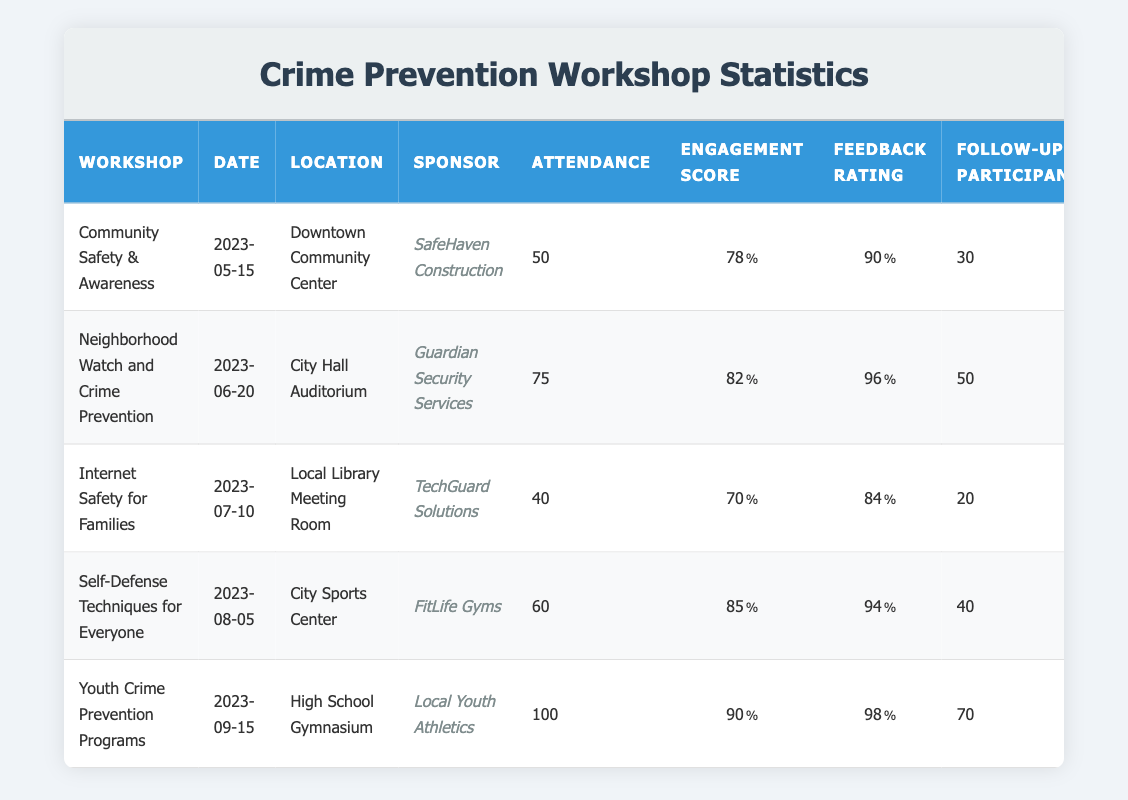What is the title of the workshop with the highest feedback rating? The table shows the feedback ratings for all workshops. The highest feedback rating is 4.9, which corresponds to the "Youth Crime Prevention Programs" workshop.
Answer: Youth Crime Prevention Programs How many follow-up participants attended the "Self-Defense Techniques for Everyone" workshop? By looking at the row for the "Self-Defense Techniques for Everyone" workshop, we find that there were 40 follow-up participants.
Answer: 40 What was the engagement score for the workshop held at the City Hall Auditorium? The workshop held at the City Hall Auditorium was "Neighborhood Watch and Crime Prevention," which has an engagement score of 82.
Answer: 82 What is the total attendance across all workshops? To find the total attendance, we need to sum the attendance figures: 50 + 75 + 40 + 60 + 100 = 325.
Answer: 325 Is it true that the workshop titled "Internet Safety for Families" had a higher engagement score than the "Community Safety & Awareness" workshop? The engagement score for "Internet Safety for Families" is 70, and for "Community Safety & Awareness," it is 78. Since 70 is less than 78, the statement is false.
Answer: False Which sponsor had the highest number of follow-up participants overall? We review the follow-up participants for each workshop: SafeHaven Construction (30), Guardian Security Services (50), TechGuard Solutions (20), FitLife Gyms (40), and Local Youth Athletics (70). Local Youth Athletics has the highest with 70 follow-up participants.
Answer: Local Youth Athletics What is the average feedback rating across all workshops? First, we add up all the feedback ratings: 4.5 + 4.8 + 4.2 + 4.7 + 4.9 = 24.1. There are 5 workshops, so the average is 24.1 / 5 = 4.82.
Answer: 4.82 How many workshops had an engagement score of 80 or higher? We check the engagement scores: 78, 82, 70, 85, and 90. The scores that are 80 or higher are 82, 85, and 90. This gives us a total of 3 workshops.
Answer: 3 Which workshop had the lowest attendance, and what was the attendance figure? Looking across the attendance column, the lowest figure is 40 for the workshop "Internet Safety for Families."
Answer: Internet Safety for Families, 40 